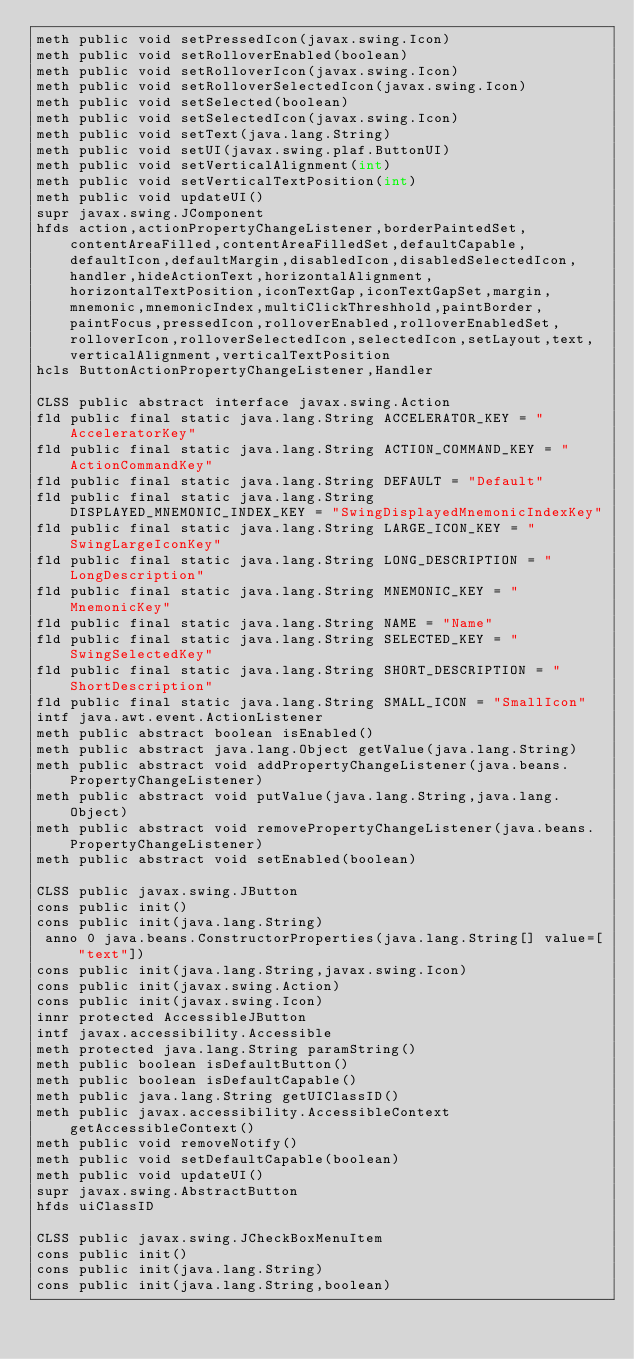<code> <loc_0><loc_0><loc_500><loc_500><_SML_>meth public void setPressedIcon(javax.swing.Icon)
meth public void setRolloverEnabled(boolean)
meth public void setRolloverIcon(javax.swing.Icon)
meth public void setRolloverSelectedIcon(javax.swing.Icon)
meth public void setSelected(boolean)
meth public void setSelectedIcon(javax.swing.Icon)
meth public void setText(java.lang.String)
meth public void setUI(javax.swing.plaf.ButtonUI)
meth public void setVerticalAlignment(int)
meth public void setVerticalTextPosition(int)
meth public void updateUI()
supr javax.swing.JComponent
hfds action,actionPropertyChangeListener,borderPaintedSet,contentAreaFilled,contentAreaFilledSet,defaultCapable,defaultIcon,defaultMargin,disabledIcon,disabledSelectedIcon,handler,hideActionText,horizontalAlignment,horizontalTextPosition,iconTextGap,iconTextGapSet,margin,mnemonic,mnemonicIndex,multiClickThreshhold,paintBorder,paintFocus,pressedIcon,rolloverEnabled,rolloverEnabledSet,rolloverIcon,rolloverSelectedIcon,selectedIcon,setLayout,text,verticalAlignment,verticalTextPosition
hcls ButtonActionPropertyChangeListener,Handler

CLSS public abstract interface javax.swing.Action
fld public final static java.lang.String ACCELERATOR_KEY = "AcceleratorKey"
fld public final static java.lang.String ACTION_COMMAND_KEY = "ActionCommandKey"
fld public final static java.lang.String DEFAULT = "Default"
fld public final static java.lang.String DISPLAYED_MNEMONIC_INDEX_KEY = "SwingDisplayedMnemonicIndexKey"
fld public final static java.lang.String LARGE_ICON_KEY = "SwingLargeIconKey"
fld public final static java.lang.String LONG_DESCRIPTION = "LongDescription"
fld public final static java.lang.String MNEMONIC_KEY = "MnemonicKey"
fld public final static java.lang.String NAME = "Name"
fld public final static java.lang.String SELECTED_KEY = "SwingSelectedKey"
fld public final static java.lang.String SHORT_DESCRIPTION = "ShortDescription"
fld public final static java.lang.String SMALL_ICON = "SmallIcon"
intf java.awt.event.ActionListener
meth public abstract boolean isEnabled()
meth public abstract java.lang.Object getValue(java.lang.String)
meth public abstract void addPropertyChangeListener(java.beans.PropertyChangeListener)
meth public abstract void putValue(java.lang.String,java.lang.Object)
meth public abstract void removePropertyChangeListener(java.beans.PropertyChangeListener)
meth public abstract void setEnabled(boolean)

CLSS public javax.swing.JButton
cons public init()
cons public init(java.lang.String)
 anno 0 java.beans.ConstructorProperties(java.lang.String[] value=["text"])
cons public init(java.lang.String,javax.swing.Icon)
cons public init(javax.swing.Action)
cons public init(javax.swing.Icon)
innr protected AccessibleJButton
intf javax.accessibility.Accessible
meth protected java.lang.String paramString()
meth public boolean isDefaultButton()
meth public boolean isDefaultCapable()
meth public java.lang.String getUIClassID()
meth public javax.accessibility.AccessibleContext getAccessibleContext()
meth public void removeNotify()
meth public void setDefaultCapable(boolean)
meth public void updateUI()
supr javax.swing.AbstractButton
hfds uiClassID

CLSS public javax.swing.JCheckBoxMenuItem
cons public init()
cons public init(java.lang.String)
cons public init(java.lang.String,boolean)</code> 